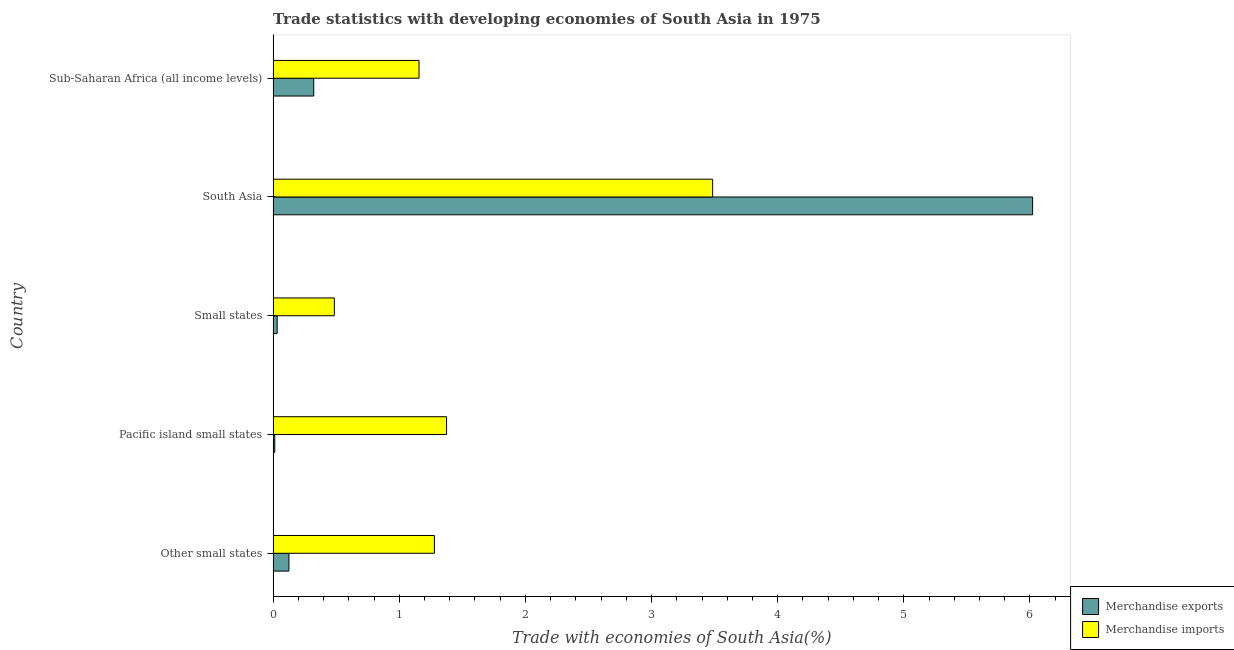Are the number of bars on each tick of the Y-axis equal?
Keep it short and to the point. Yes. What is the label of the 5th group of bars from the top?
Ensure brevity in your answer.  Other small states. What is the merchandise exports in Pacific island small states?
Ensure brevity in your answer.  0.01. Across all countries, what is the maximum merchandise imports?
Offer a very short reply. 3.48. Across all countries, what is the minimum merchandise imports?
Make the answer very short. 0.49. In which country was the merchandise exports minimum?
Give a very brief answer. Pacific island small states. What is the total merchandise exports in the graph?
Offer a terse response. 6.51. What is the difference between the merchandise imports in Other small states and that in Small states?
Provide a short and direct response. 0.79. What is the difference between the merchandise exports in Small states and the merchandise imports in Sub-Saharan Africa (all income levels)?
Make the answer very short. -1.12. What is the average merchandise exports per country?
Ensure brevity in your answer.  1.3. What is the difference between the merchandise imports and merchandise exports in Small states?
Your answer should be compact. 0.45. What is the ratio of the merchandise exports in Other small states to that in South Asia?
Give a very brief answer. 0.02. Is the merchandise exports in Other small states less than that in Pacific island small states?
Your answer should be compact. No. Is the difference between the merchandise exports in South Asia and Sub-Saharan Africa (all income levels) greater than the difference between the merchandise imports in South Asia and Sub-Saharan Africa (all income levels)?
Offer a very short reply. Yes. What is the difference between the highest and the second highest merchandise imports?
Offer a terse response. 2.11. What is the difference between the highest and the lowest merchandise imports?
Your response must be concise. 3. Is the sum of the merchandise exports in Other small states and Small states greater than the maximum merchandise imports across all countries?
Your response must be concise. No. What does the 1st bar from the top in Small states represents?
Ensure brevity in your answer.  Merchandise imports. What does the 1st bar from the bottom in South Asia represents?
Offer a terse response. Merchandise exports. Are all the bars in the graph horizontal?
Offer a terse response. Yes. What is the difference between two consecutive major ticks on the X-axis?
Your answer should be compact. 1. Are the values on the major ticks of X-axis written in scientific E-notation?
Offer a terse response. No. How many legend labels are there?
Ensure brevity in your answer.  2. How are the legend labels stacked?
Give a very brief answer. Vertical. What is the title of the graph?
Make the answer very short. Trade statistics with developing economies of South Asia in 1975. Does "Borrowers" appear as one of the legend labels in the graph?
Provide a short and direct response. No. What is the label or title of the X-axis?
Give a very brief answer. Trade with economies of South Asia(%). What is the label or title of the Y-axis?
Offer a very short reply. Country. What is the Trade with economies of South Asia(%) of Merchandise exports in Other small states?
Provide a short and direct response. 0.13. What is the Trade with economies of South Asia(%) of Merchandise imports in Other small states?
Offer a terse response. 1.28. What is the Trade with economies of South Asia(%) of Merchandise exports in Pacific island small states?
Make the answer very short. 0.01. What is the Trade with economies of South Asia(%) in Merchandise imports in Pacific island small states?
Your answer should be compact. 1.37. What is the Trade with economies of South Asia(%) in Merchandise exports in Small states?
Your answer should be compact. 0.03. What is the Trade with economies of South Asia(%) of Merchandise imports in Small states?
Your response must be concise. 0.49. What is the Trade with economies of South Asia(%) in Merchandise exports in South Asia?
Keep it short and to the point. 6.02. What is the Trade with economies of South Asia(%) in Merchandise imports in South Asia?
Make the answer very short. 3.48. What is the Trade with economies of South Asia(%) in Merchandise exports in Sub-Saharan Africa (all income levels)?
Give a very brief answer. 0.32. What is the Trade with economies of South Asia(%) of Merchandise imports in Sub-Saharan Africa (all income levels)?
Give a very brief answer. 1.16. Across all countries, what is the maximum Trade with economies of South Asia(%) of Merchandise exports?
Your answer should be very brief. 6.02. Across all countries, what is the maximum Trade with economies of South Asia(%) of Merchandise imports?
Provide a succinct answer. 3.48. Across all countries, what is the minimum Trade with economies of South Asia(%) in Merchandise exports?
Make the answer very short. 0.01. Across all countries, what is the minimum Trade with economies of South Asia(%) in Merchandise imports?
Provide a short and direct response. 0.49. What is the total Trade with economies of South Asia(%) of Merchandise exports in the graph?
Make the answer very short. 6.51. What is the total Trade with economies of South Asia(%) in Merchandise imports in the graph?
Provide a short and direct response. 7.78. What is the difference between the Trade with economies of South Asia(%) in Merchandise exports in Other small states and that in Pacific island small states?
Provide a succinct answer. 0.11. What is the difference between the Trade with economies of South Asia(%) of Merchandise imports in Other small states and that in Pacific island small states?
Your answer should be very brief. -0.1. What is the difference between the Trade with economies of South Asia(%) of Merchandise exports in Other small states and that in Small states?
Your answer should be compact. 0.09. What is the difference between the Trade with economies of South Asia(%) of Merchandise imports in Other small states and that in Small states?
Keep it short and to the point. 0.79. What is the difference between the Trade with economies of South Asia(%) of Merchandise exports in Other small states and that in South Asia?
Offer a terse response. -5.9. What is the difference between the Trade with economies of South Asia(%) of Merchandise imports in Other small states and that in South Asia?
Provide a short and direct response. -2.21. What is the difference between the Trade with economies of South Asia(%) of Merchandise exports in Other small states and that in Sub-Saharan Africa (all income levels)?
Give a very brief answer. -0.2. What is the difference between the Trade with economies of South Asia(%) of Merchandise imports in Other small states and that in Sub-Saharan Africa (all income levels)?
Your response must be concise. 0.12. What is the difference between the Trade with economies of South Asia(%) of Merchandise exports in Pacific island small states and that in Small states?
Give a very brief answer. -0.02. What is the difference between the Trade with economies of South Asia(%) in Merchandise imports in Pacific island small states and that in Small states?
Make the answer very short. 0.89. What is the difference between the Trade with economies of South Asia(%) in Merchandise exports in Pacific island small states and that in South Asia?
Your answer should be very brief. -6.01. What is the difference between the Trade with economies of South Asia(%) of Merchandise imports in Pacific island small states and that in South Asia?
Provide a succinct answer. -2.11. What is the difference between the Trade with economies of South Asia(%) of Merchandise exports in Pacific island small states and that in Sub-Saharan Africa (all income levels)?
Your answer should be compact. -0.31. What is the difference between the Trade with economies of South Asia(%) of Merchandise imports in Pacific island small states and that in Sub-Saharan Africa (all income levels)?
Offer a terse response. 0.22. What is the difference between the Trade with economies of South Asia(%) of Merchandise exports in Small states and that in South Asia?
Your answer should be compact. -5.99. What is the difference between the Trade with economies of South Asia(%) in Merchandise imports in Small states and that in South Asia?
Keep it short and to the point. -3. What is the difference between the Trade with economies of South Asia(%) in Merchandise exports in Small states and that in Sub-Saharan Africa (all income levels)?
Your response must be concise. -0.29. What is the difference between the Trade with economies of South Asia(%) of Merchandise imports in Small states and that in Sub-Saharan Africa (all income levels)?
Offer a terse response. -0.67. What is the difference between the Trade with economies of South Asia(%) in Merchandise exports in South Asia and that in Sub-Saharan Africa (all income levels)?
Make the answer very short. 5.7. What is the difference between the Trade with economies of South Asia(%) in Merchandise imports in South Asia and that in Sub-Saharan Africa (all income levels)?
Provide a short and direct response. 2.33. What is the difference between the Trade with economies of South Asia(%) in Merchandise exports in Other small states and the Trade with economies of South Asia(%) in Merchandise imports in Pacific island small states?
Your response must be concise. -1.25. What is the difference between the Trade with economies of South Asia(%) of Merchandise exports in Other small states and the Trade with economies of South Asia(%) of Merchandise imports in Small states?
Provide a short and direct response. -0.36. What is the difference between the Trade with economies of South Asia(%) in Merchandise exports in Other small states and the Trade with economies of South Asia(%) in Merchandise imports in South Asia?
Offer a very short reply. -3.36. What is the difference between the Trade with economies of South Asia(%) of Merchandise exports in Other small states and the Trade with economies of South Asia(%) of Merchandise imports in Sub-Saharan Africa (all income levels)?
Make the answer very short. -1.03. What is the difference between the Trade with economies of South Asia(%) of Merchandise exports in Pacific island small states and the Trade with economies of South Asia(%) of Merchandise imports in Small states?
Your answer should be compact. -0.47. What is the difference between the Trade with economies of South Asia(%) of Merchandise exports in Pacific island small states and the Trade with economies of South Asia(%) of Merchandise imports in South Asia?
Provide a succinct answer. -3.47. What is the difference between the Trade with economies of South Asia(%) in Merchandise exports in Pacific island small states and the Trade with economies of South Asia(%) in Merchandise imports in Sub-Saharan Africa (all income levels)?
Give a very brief answer. -1.14. What is the difference between the Trade with economies of South Asia(%) in Merchandise exports in Small states and the Trade with economies of South Asia(%) in Merchandise imports in South Asia?
Offer a terse response. -3.45. What is the difference between the Trade with economies of South Asia(%) of Merchandise exports in Small states and the Trade with economies of South Asia(%) of Merchandise imports in Sub-Saharan Africa (all income levels)?
Your response must be concise. -1.12. What is the difference between the Trade with economies of South Asia(%) of Merchandise exports in South Asia and the Trade with economies of South Asia(%) of Merchandise imports in Sub-Saharan Africa (all income levels)?
Provide a short and direct response. 4.86. What is the average Trade with economies of South Asia(%) of Merchandise exports per country?
Your response must be concise. 1.3. What is the average Trade with economies of South Asia(%) in Merchandise imports per country?
Offer a very short reply. 1.56. What is the difference between the Trade with economies of South Asia(%) in Merchandise exports and Trade with economies of South Asia(%) in Merchandise imports in Other small states?
Offer a very short reply. -1.15. What is the difference between the Trade with economies of South Asia(%) of Merchandise exports and Trade with economies of South Asia(%) of Merchandise imports in Pacific island small states?
Provide a succinct answer. -1.36. What is the difference between the Trade with economies of South Asia(%) in Merchandise exports and Trade with economies of South Asia(%) in Merchandise imports in Small states?
Offer a terse response. -0.45. What is the difference between the Trade with economies of South Asia(%) in Merchandise exports and Trade with economies of South Asia(%) in Merchandise imports in South Asia?
Keep it short and to the point. 2.54. What is the difference between the Trade with economies of South Asia(%) in Merchandise exports and Trade with economies of South Asia(%) in Merchandise imports in Sub-Saharan Africa (all income levels)?
Provide a short and direct response. -0.83. What is the ratio of the Trade with economies of South Asia(%) of Merchandise exports in Other small states to that in Pacific island small states?
Your answer should be compact. 9.63. What is the ratio of the Trade with economies of South Asia(%) of Merchandise imports in Other small states to that in Pacific island small states?
Offer a terse response. 0.93. What is the ratio of the Trade with economies of South Asia(%) in Merchandise exports in Other small states to that in Small states?
Make the answer very short. 3.91. What is the ratio of the Trade with economies of South Asia(%) in Merchandise imports in Other small states to that in Small states?
Keep it short and to the point. 2.63. What is the ratio of the Trade with economies of South Asia(%) of Merchandise exports in Other small states to that in South Asia?
Your response must be concise. 0.02. What is the ratio of the Trade with economies of South Asia(%) of Merchandise imports in Other small states to that in South Asia?
Ensure brevity in your answer.  0.37. What is the ratio of the Trade with economies of South Asia(%) in Merchandise exports in Other small states to that in Sub-Saharan Africa (all income levels)?
Your response must be concise. 0.39. What is the ratio of the Trade with economies of South Asia(%) in Merchandise imports in Other small states to that in Sub-Saharan Africa (all income levels)?
Offer a terse response. 1.11. What is the ratio of the Trade with economies of South Asia(%) in Merchandise exports in Pacific island small states to that in Small states?
Provide a short and direct response. 0.41. What is the ratio of the Trade with economies of South Asia(%) in Merchandise imports in Pacific island small states to that in Small states?
Make the answer very short. 2.83. What is the ratio of the Trade with economies of South Asia(%) in Merchandise exports in Pacific island small states to that in South Asia?
Give a very brief answer. 0. What is the ratio of the Trade with economies of South Asia(%) of Merchandise imports in Pacific island small states to that in South Asia?
Offer a very short reply. 0.39. What is the ratio of the Trade with economies of South Asia(%) in Merchandise exports in Pacific island small states to that in Sub-Saharan Africa (all income levels)?
Provide a succinct answer. 0.04. What is the ratio of the Trade with economies of South Asia(%) of Merchandise imports in Pacific island small states to that in Sub-Saharan Africa (all income levels)?
Your answer should be compact. 1.19. What is the ratio of the Trade with economies of South Asia(%) in Merchandise exports in Small states to that in South Asia?
Keep it short and to the point. 0.01. What is the ratio of the Trade with economies of South Asia(%) in Merchandise imports in Small states to that in South Asia?
Offer a terse response. 0.14. What is the ratio of the Trade with economies of South Asia(%) in Merchandise exports in Small states to that in Sub-Saharan Africa (all income levels)?
Offer a very short reply. 0.1. What is the ratio of the Trade with economies of South Asia(%) of Merchandise imports in Small states to that in Sub-Saharan Africa (all income levels)?
Provide a short and direct response. 0.42. What is the ratio of the Trade with economies of South Asia(%) in Merchandise exports in South Asia to that in Sub-Saharan Africa (all income levels)?
Give a very brief answer. 18.71. What is the ratio of the Trade with economies of South Asia(%) in Merchandise imports in South Asia to that in Sub-Saharan Africa (all income levels)?
Provide a succinct answer. 3.01. What is the difference between the highest and the second highest Trade with economies of South Asia(%) of Merchandise exports?
Keep it short and to the point. 5.7. What is the difference between the highest and the second highest Trade with economies of South Asia(%) in Merchandise imports?
Make the answer very short. 2.11. What is the difference between the highest and the lowest Trade with economies of South Asia(%) in Merchandise exports?
Make the answer very short. 6.01. What is the difference between the highest and the lowest Trade with economies of South Asia(%) of Merchandise imports?
Make the answer very short. 3. 